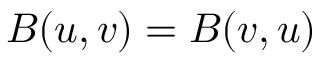Convert formula to latex. <formula><loc_0><loc_0><loc_500><loc_500>B ( u , v ) = B ( v , u )</formula> 